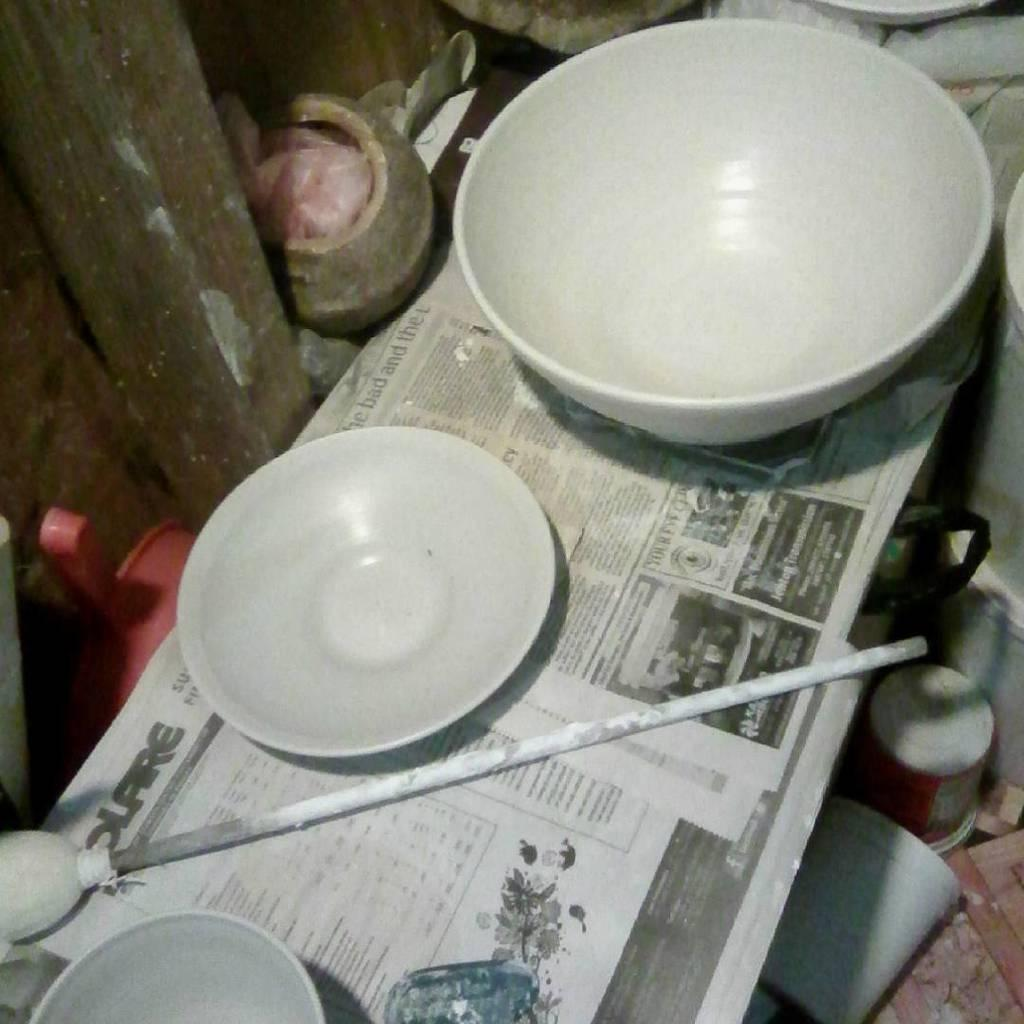What type of containers can be seen in the image? There are bowls, a plate, and cups in the image. What other items are present in the image? There is a rod, a newspaper, a platform, a wooden pole, a cover in a pot, and other objects in the image. What grade is the daughter in the class depicted in the image? There is no daughter or class present in the image. How deep are the roots of the plant growing near the wooden pole in the image? There is no plant or roots visible in the image; only a wooden pole is present. 